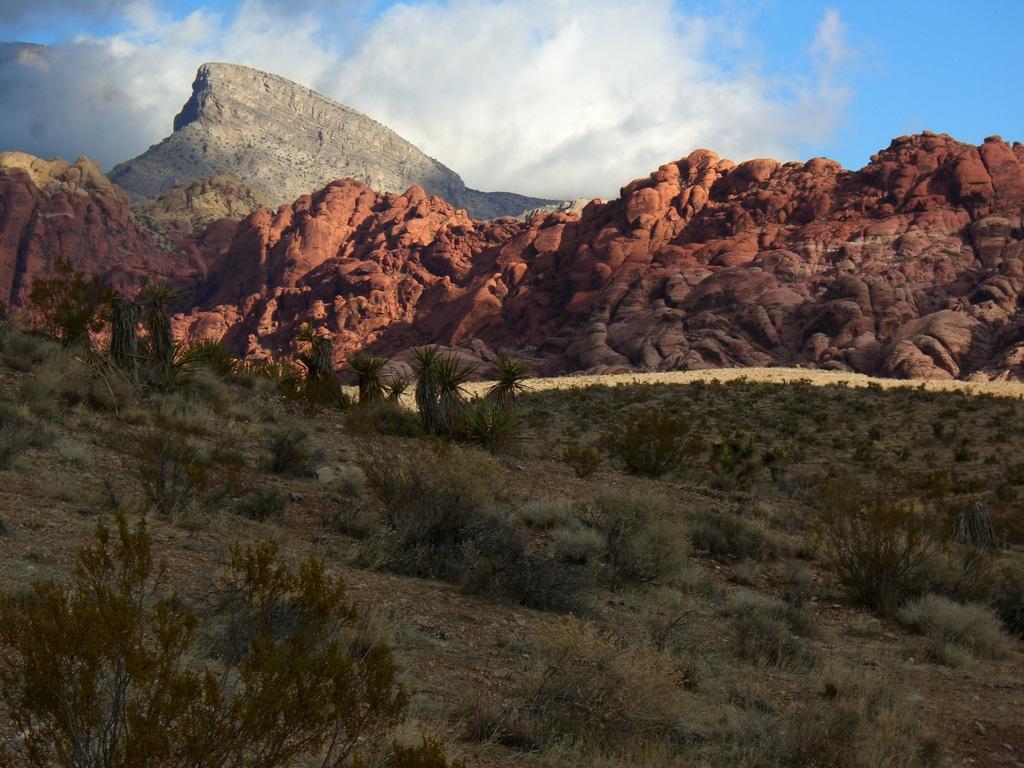How would you summarize this image in a sentence or two? In this image I see the ground on which there is grass and plants. In the background I see the mountains and the sky which is of blue and white in color. 